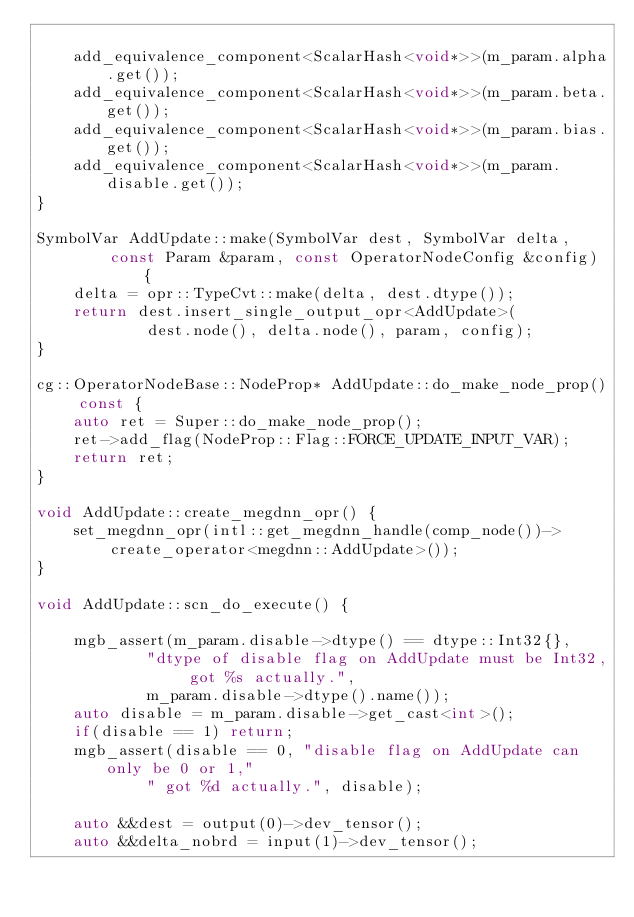Convert code to text. <code><loc_0><loc_0><loc_500><loc_500><_C++_>
    add_equivalence_component<ScalarHash<void*>>(m_param.alpha.get());
    add_equivalence_component<ScalarHash<void*>>(m_param.beta.get());
    add_equivalence_component<ScalarHash<void*>>(m_param.bias.get());
    add_equivalence_component<ScalarHash<void*>>(m_param.disable.get());
}

SymbolVar AddUpdate::make(SymbolVar dest, SymbolVar delta,
        const Param &param, const OperatorNodeConfig &config) {
    delta = opr::TypeCvt::make(delta, dest.dtype());
    return dest.insert_single_output_opr<AddUpdate>(
            dest.node(), delta.node(), param, config);
}

cg::OperatorNodeBase::NodeProp* AddUpdate::do_make_node_prop() const {
    auto ret = Super::do_make_node_prop();
    ret->add_flag(NodeProp::Flag::FORCE_UPDATE_INPUT_VAR);
    return ret;
}

void AddUpdate::create_megdnn_opr() {
    set_megdnn_opr(intl::get_megdnn_handle(comp_node())->
        create_operator<megdnn::AddUpdate>());
}

void AddUpdate::scn_do_execute() {

    mgb_assert(m_param.disable->dtype() == dtype::Int32{},
            "dtype of disable flag on AddUpdate must be Int32, got %s actually.",
            m_param.disable->dtype().name());
    auto disable = m_param.disable->get_cast<int>();
    if(disable == 1) return;
    mgb_assert(disable == 0, "disable flag on AddUpdate can only be 0 or 1,"
            " got %d actually.", disable);

    auto &&dest = output(0)->dev_tensor();
    auto &&delta_nobrd = input(1)->dev_tensor();</code> 